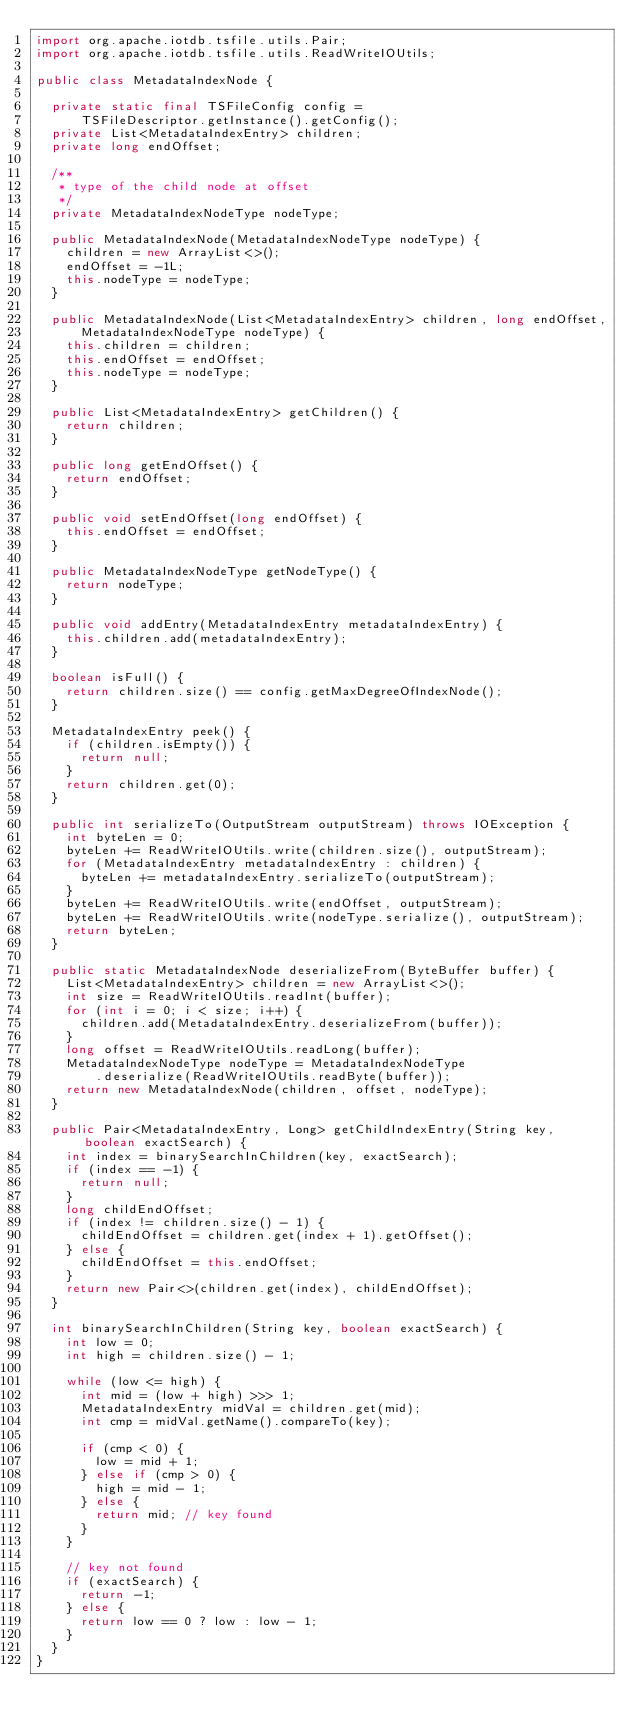Convert code to text. <code><loc_0><loc_0><loc_500><loc_500><_Java_>import org.apache.iotdb.tsfile.utils.Pair;
import org.apache.iotdb.tsfile.utils.ReadWriteIOUtils;

public class MetadataIndexNode {

  private static final TSFileConfig config =
      TSFileDescriptor.getInstance().getConfig();
  private List<MetadataIndexEntry> children;
  private long endOffset;

  /**
   * type of the child node at offset
   */
  private MetadataIndexNodeType nodeType;

  public MetadataIndexNode(MetadataIndexNodeType nodeType) {
    children = new ArrayList<>();
    endOffset = -1L;
    this.nodeType = nodeType;
  }

  public MetadataIndexNode(List<MetadataIndexEntry> children, long endOffset,
      MetadataIndexNodeType nodeType) {
    this.children = children;
    this.endOffset = endOffset;
    this.nodeType = nodeType;
  }

  public List<MetadataIndexEntry> getChildren() {
    return children;
  }

  public long getEndOffset() {
    return endOffset;
  }

  public void setEndOffset(long endOffset) {
    this.endOffset = endOffset;
  }

  public MetadataIndexNodeType getNodeType() {
    return nodeType;
  }

  public void addEntry(MetadataIndexEntry metadataIndexEntry) {
    this.children.add(metadataIndexEntry);
  }

  boolean isFull() {
    return children.size() == config.getMaxDegreeOfIndexNode();
  }

  MetadataIndexEntry peek() {
    if (children.isEmpty()) {
      return null;
    }
    return children.get(0);
  }

  public int serializeTo(OutputStream outputStream) throws IOException {
    int byteLen = 0;
    byteLen += ReadWriteIOUtils.write(children.size(), outputStream);
    for (MetadataIndexEntry metadataIndexEntry : children) {
      byteLen += metadataIndexEntry.serializeTo(outputStream);
    }
    byteLen += ReadWriteIOUtils.write(endOffset, outputStream);
    byteLen += ReadWriteIOUtils.write(nodeType.serialize(), outputStream);
    return byteLen;
  }

  public static MetadataIndexNode deserializeFrom(ByteBuffer buffer) {
    List<MetadataIndexEntry> children = new ArrayList<>();
    int size = ReadWriteIOUtils.readInt(buffer);
    for (int i = 0; i < size; i++) {
      children.add(MetadataIndexEntry.deserializeFrom(buffer));
    }
    long offset = ReadWriteIOUtils.readLong(buffer);
    MetadataIndexNodeType nodeType = MetadataIndexNodeType
        .deserialize(ReadWriteIOUtils.readByte(buffer));
    return new MetadataIndexNode(children, offset, nodeType);
  }

  public Pair<MetadataIndexEntry, Long> getChildIndexEntry(String key, boolean exactSearch) {
    int index = binarySearchInChildren(key, exactSearch);
    if (index == -1) {
      return null;
    }
    long childEndOffset;
    if (index != children.size() - 1) {
      childEndOffset = children.get(index + 1).getOffset();
    } else {
      childEndOffset = this.endOffset;
    }
    return new Pair<>(children.get(index), childEndOffset);
  }

  int binarySearchInChildren(String key, boolean exactSearch) {
    int low = 0;
    int high = children.size() - 1;

    while (low <= high) {
      int mid = (low + high) >>> 1;
      MetadataIndexEntry midVal = children.get(mid);
      int cmp = midVal.getName().compareTo(key);

      if (cmp < 0) {
        low = mid + 1;
      } else if (cmp > 0) {
        high = mid - 1;
      } else {
        return mid; // key found
      }
    }

    // key not found
    if (exactSearch) {
      return -1;
    } else {
      return low == 0 ? low : low - 1;
    }
  }
}
</code> 